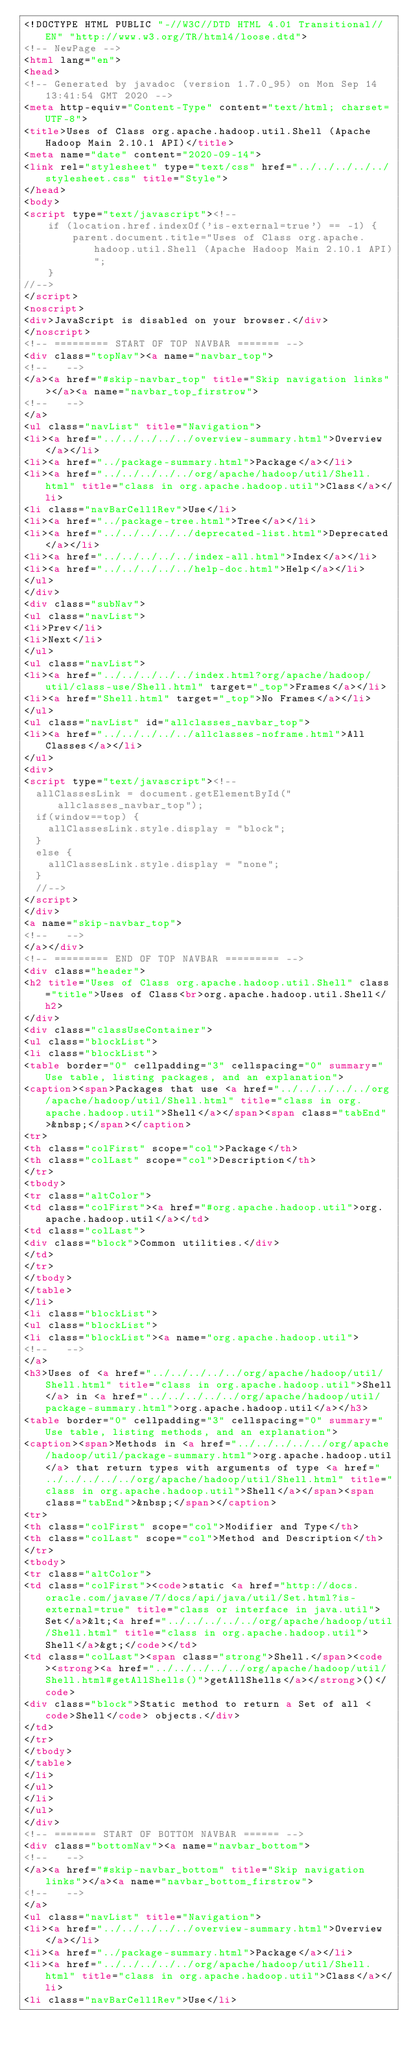Convert code to text. <code><loc_0><loc_0><loc_500><loc_500><_HTML_><!DOCTYPE HTML PUBLIC "-//W3C//DTD HTML 4.01 Transitional//EN" "http://www.w3.org/TR/html4/loose.dtd">
<!-- NewPage -->
<html lang="en">
<head>
<!-- Generated by javadoc (version 1.7.0_95) on Mon Sep 14 13:41:54 GMT 2020 -->
<meta http-equiv="Content-Type" content="text/html; charset=UTF-8">
<title>Uses of Class org.apache.hadoop.util.Shell (Apache Hadoop Main 2.10.1 API)</title>
<meta name="date" content="2020-09-14">
<link rel="stylesheet" type="text/css" href="../../../../../stylesheet.css" title="Style">
</head>
<body>
<script type="text/javascript"><!--
    if (location.href.indexOf('is-external=true') == -1) {
        parent.document.title="Uses of Class org.apache.hadoop.util.Shell (Apache Hadoop Main 2.10.1 API)";
    }
//-->
</script>
<noscript>
<div>JavaScript is disabled on your browser.</div>
</noscript>
<!-- ========= START OF TOP NAVBAR ======= -->
<div class="topNav"><a name="navbar_top">
<!--   -->
</a><a href="#skip-navbar_top" title="Skip navigation links"></a><a name="navbar_top_firstrow">
<!--   -->
</a>
<ul class="navList" title="Navigation">
<li><a href="../../../../../overview-summary.html">Overview</a></li>
<li><a href="../package-summary.html">Package</a></li>
<li><a href="../../../../../org/apache/hadoop/util/Shell.html" title="class in org.apache.hadoop.util">Class</a></li>
<li class="navBarCell1Rev">Use</li>
<li><a href="../package-tree.html">Tree</a></li>
<li><a href="../../../../../deprecated-list.html">Deprecated</a></li>
<li><a href="../../../../../index-all.html">Index</a></li>
<li><a href="../../../../../help-doc.html">Help</a></li>
</ul>
</div>
<div class="subNav">
<ul class="navList">
<li>Prev</li>
<li>Next</li>
</ul>
<ul class="navList">
<li><a href="../../../../../index.html?org/apache/hadoop/util/class-use/Shell.html" target="_top">Frames</a></li>
<li><a href="Shell.html" target="_top">No Frames</a></li>
</ul>
<ul class="navList" id="allclasses_navbar_top">
<li><a href="../../../../../allclasses-noframe.html">All Classes</a></li>
</ul>
<div>
<script type="text/javascript"><!--
  allClassesLink = document.getElementById("allclasses_navbar_top");
  if(window==top) {
    allClassesLink.style.display = "block";
  }
  else {
    allClassesLink.style.display = "none";
  }
  //-->
</script>
</div>
<a name="skip-navbar_top">
<!--   -->
</a></div>
<!-- ========= END OF TOP NAVBAR ========= -->
<div class="header">
<h2 title="Uses of Class org.apache.hadoop.util.Shell" class="title">Uses of Class<br>org.apache.hadoop.util.Shell</h2>
</div>
<div class="classUseContainer">
<ul class="blockList">
<li class="blockList">
<table border="0" cellpadding="3" cellspacing="0" summary="Use table, listing packages, and an explanation">
<caption><span>Packages that use <a href="../../../../../org/apache/hadoop/util/Shell.html" title="class in org.apache.hadoop.util">Shell</a></span><span class="tabEnd">&nbsp;</span></caption>
<tr>
<th class="colFirst" scope="col">Package</th>
<th class="colLast" scope="col">Description</th>
</tr>
<tbody>
<tr class="altColor">
<td class="colFirst"><a href="#org.apache.hadoop.util">org.apache.hadoop.util</a></td>
<td class="colLast">
<div class="block">Common utilities.</div>
</td>
</tr>
</tbody>
</table>
</li>
<li class="blockList">
<ul class="blockList">
<li class="blockList"><a name="org.apache.hadoop.util">
<!--   -->
</a>
<h3>Uses of <a href="../../../../../org/apache/hadoop/util/Shell.html" title="class in org.apache.hadoop.util">Shell</a> in <a href="../../../../../org/apache/hadoop/util/package-summary.html">org.apache.hadoop.util</a></h3>
<table border="0" cellpadding="3" cellspacing="0" summary="Use table, listing methods, and an explanation">
<caption><span>Methods in <a href="../../../../../org/apache/hadoop/util/package-summary.html">org.apache.hadoop.util</a> that return types with arguments of type <a href="../../../../../org/apache/hadoop/util/Shell.html" title="class in org.apache.hadoop.util">Shell</a></span><span class="tabEnd">&nbsp;</span></caption>
<tr>
<th class="colFirst" scope="col">Modifier and Type</th>
<th class="colLast" scope="col">Method and Description</th>
</tr>
<tbody>
<tr class="altColor">
<td class="colFirst"><code>static <a href="http://docs.oracle.com/javase/7/docs/api/java/util/Set.html?is-external=true" title="class or interface in java.util">Set</a>&lt;<a href="../../../../../org/apache/hadoop/util/Shell.html" title="class in org.apache.hadoop.util">Shell</a>&gt;</code></td>
<td class="colLast"><span class="strong">Shell.</span><code><strong><a href="../../../../../org/apache/hadoop/util/Shell.html#getAllShells()">getAllShells</a></strong>()</code>
<div class="block">Static method to return a Set of all <code>Shell</code> objects.</div>
</td>
</tr>
</tbody>
</table>
</li>
</ul>
</li>
</ul>
</div>
<!-- ======= START OF BOTTOM NAVBAR ====== -->
<div class="bottomNav"><a name="navbar_bottom">
<!--   -->
</a><a href="#skip-navbar_bottom" title="Skip navigation links"></a><a name="navbar_bottom_firstrow">
<!--   -->
</a>
<ul class="navList" title="Navigation">
<li><a href="../../../../../overview-summary.html">Overview</a></li>
<li><a href="../package-summary.html">Package</a></li>
<li><a href="../../../../../org/apache/hadoop/util/Shell.html" title="class in org.apache.hadoop.util">Class</a></li>
<li class="navBarCell1Rev">Use</li></code> 